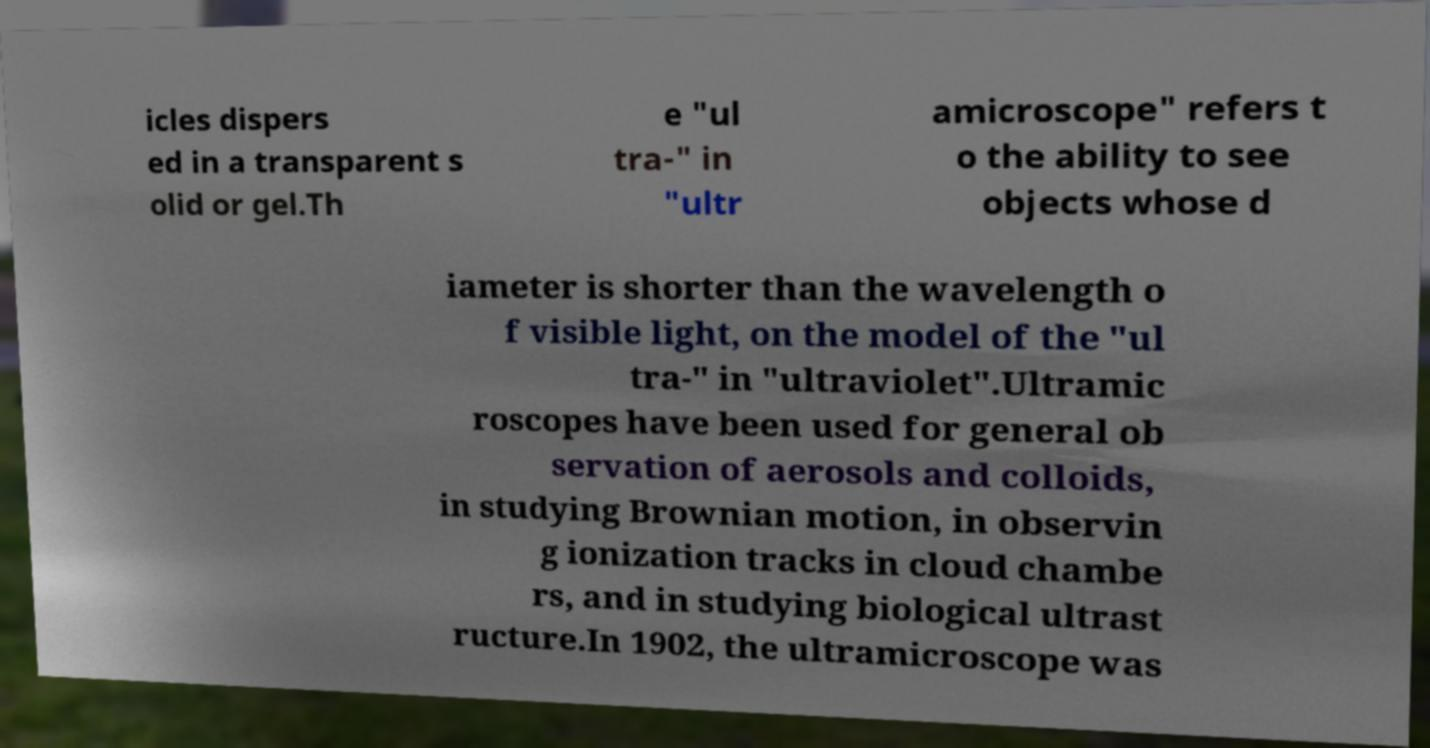There's text embedded in this image that I need extracted. Can you transcribe it verbatim? icles dispers ed in a transparent s olid or gel.Th e "ul tra-" in "ultr amicroscope" refers t o the ability to see objects whose d iameter is shorter than the wavelength o f visible light, on the model of the "ul tra-" in "ultraviolet".Ultramic roscopes have been used for general ob servation of aerosols and colloids, in studying Brownian motion, in observin g ionization tracks in cloud chambe rs, and in studying biological ultrast ructure.In 1902, the ultramicroscope was 